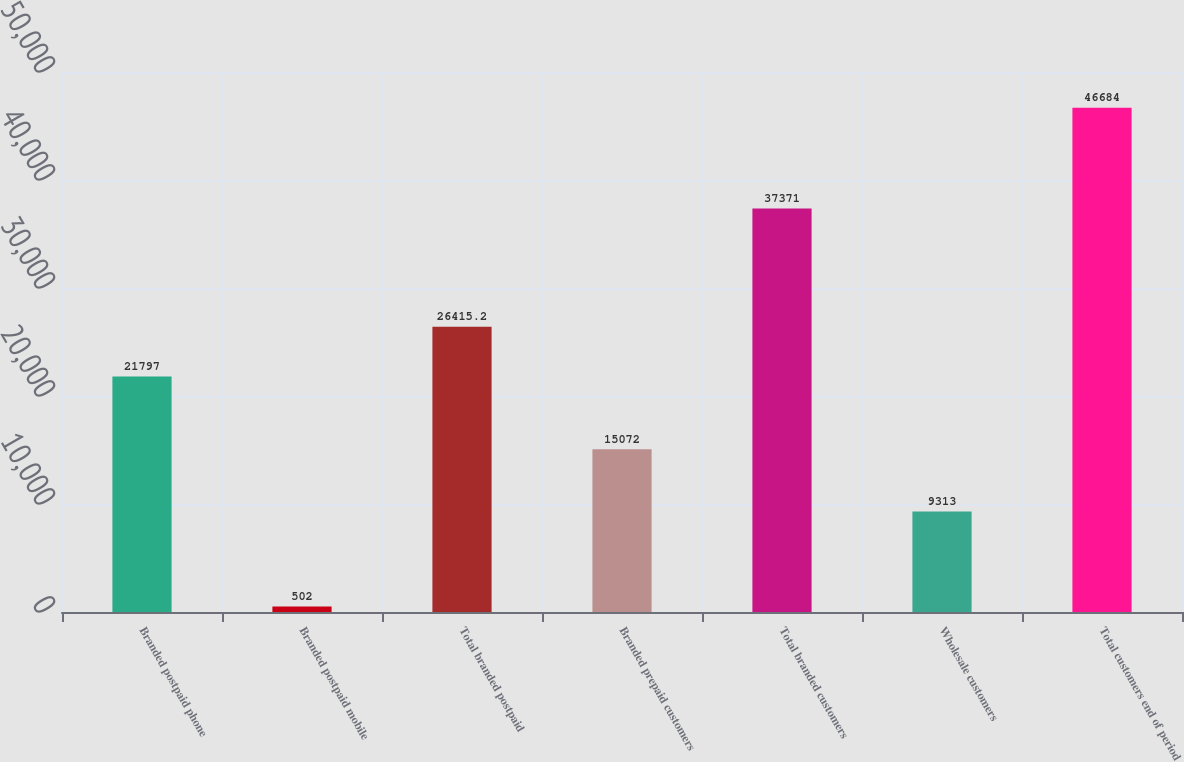<chart> <loc_0><loc_0><loc_500><loc_500><bar_chart><fcel>Branded postpaid phone<fcel>Branded postpaid mobile<fcel>Total branded postpaid<fcel>Branded prepaid customers<fcel>Total branded customers<fcel>Wholesale customers<fcel>Total customers end of period<nl><fcel>21797<fcel>502<fcel>26415.2<fcel>15072<fcel>37371<fcel>9313<fcel>46684<nl></chart> 